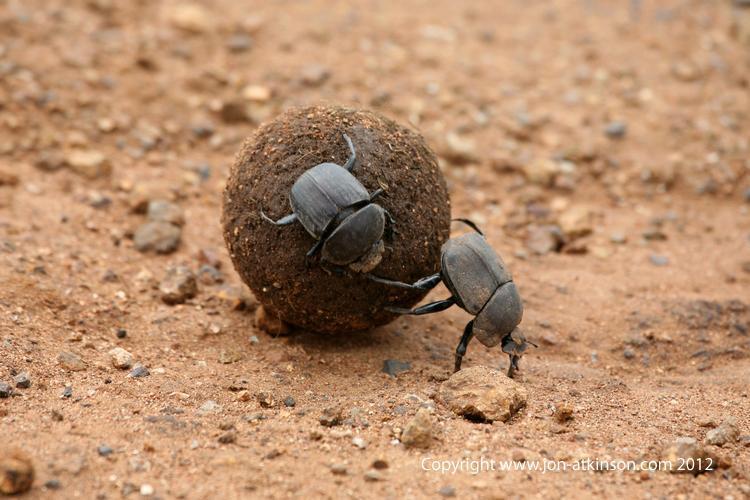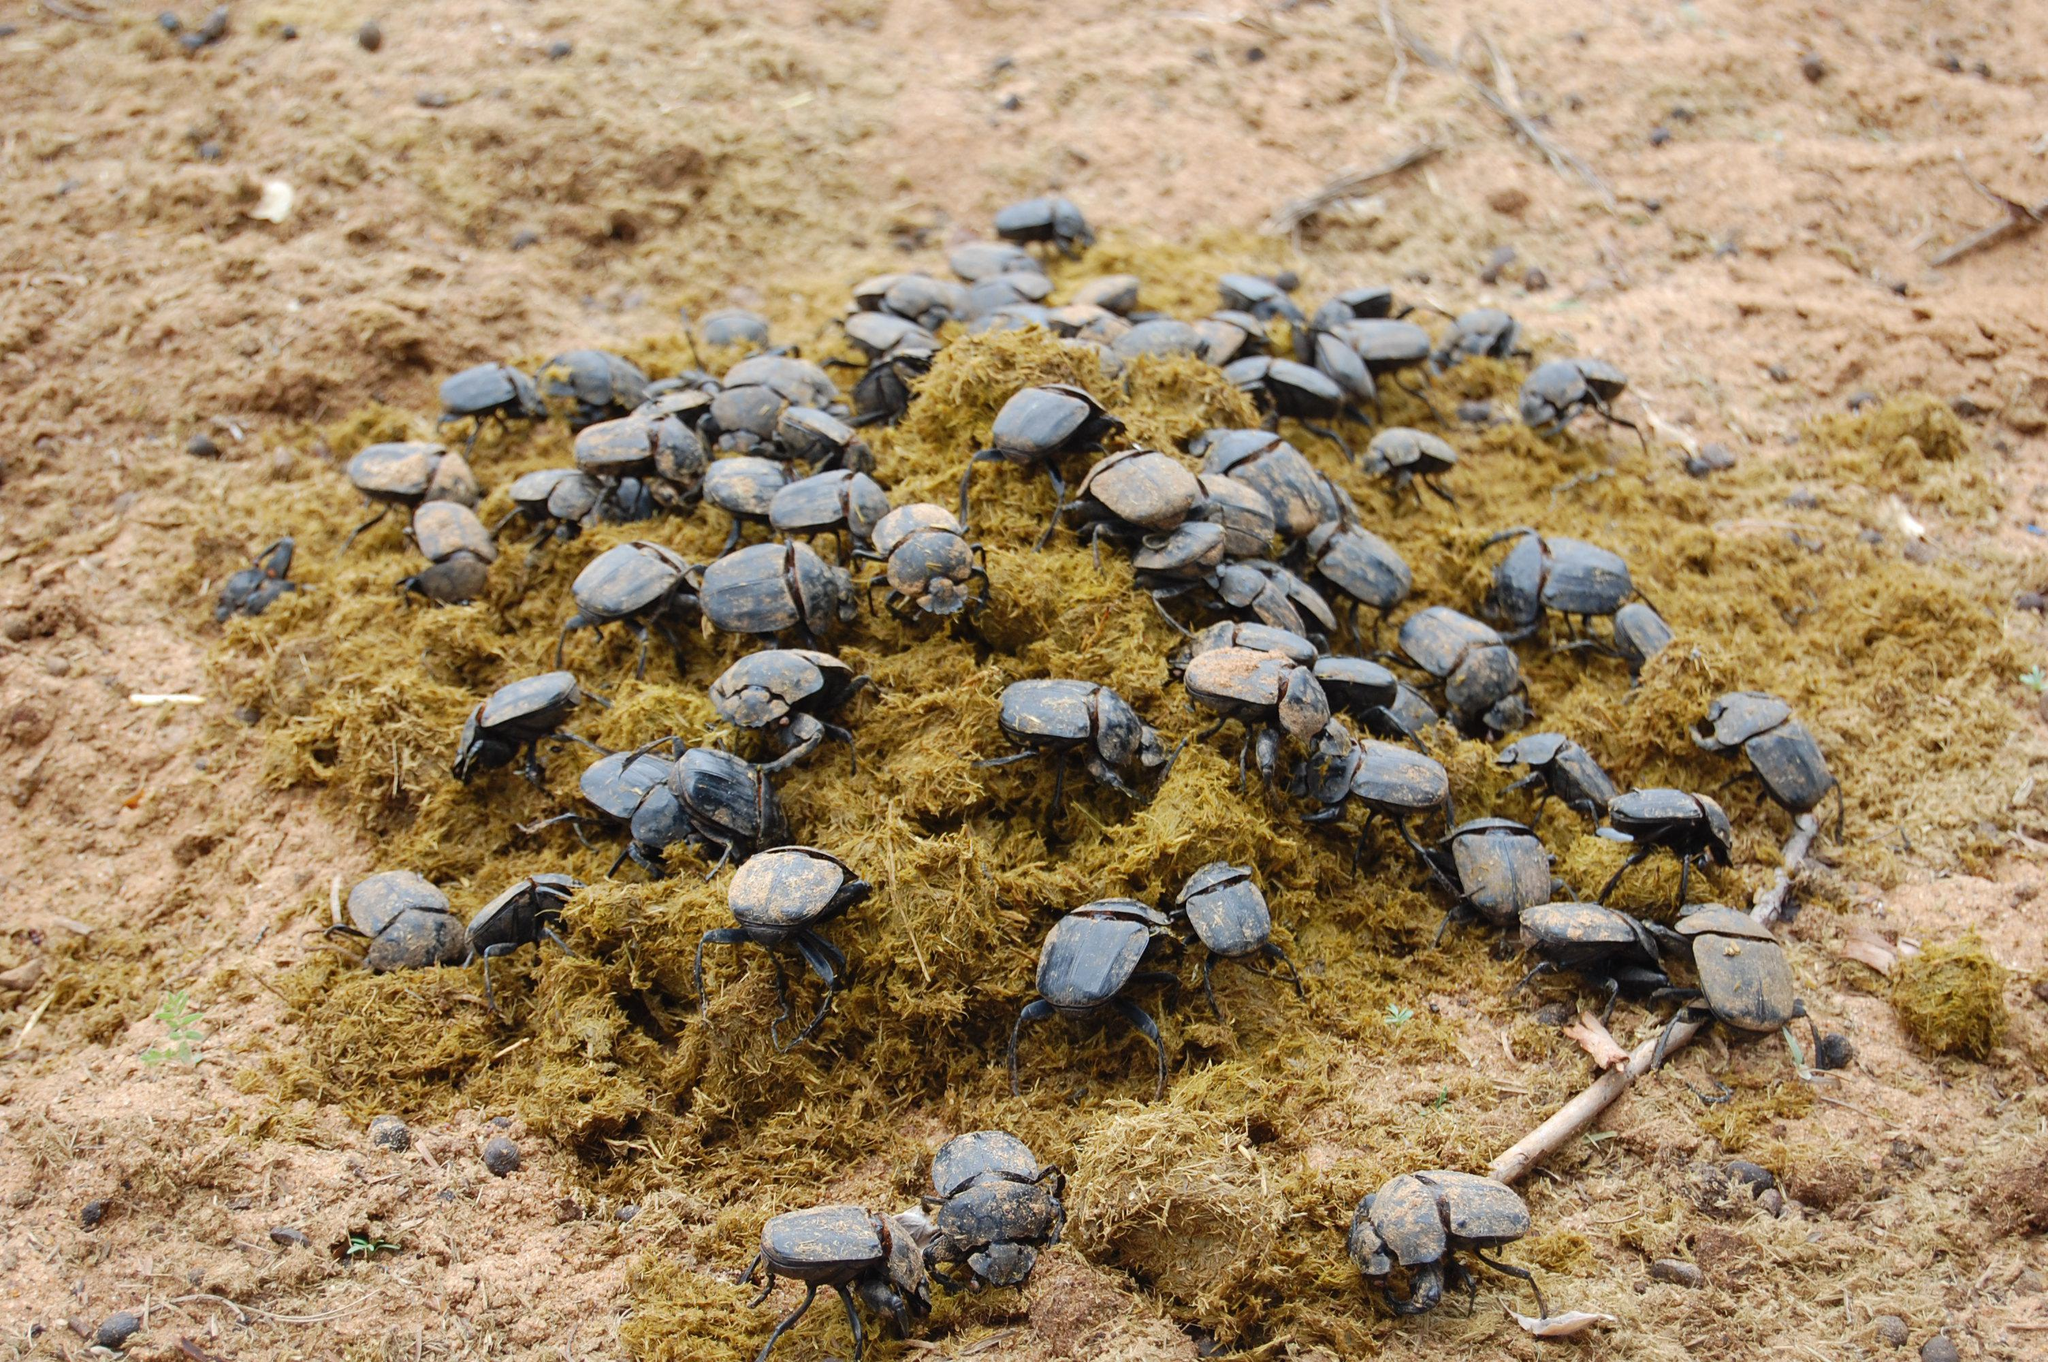The first image is the image on the left, the second image is the image on the right. Examine the images to the left and right. Is the description "One image has more than 20 dung beetles." accurate? Answer yes or no. Yes. 